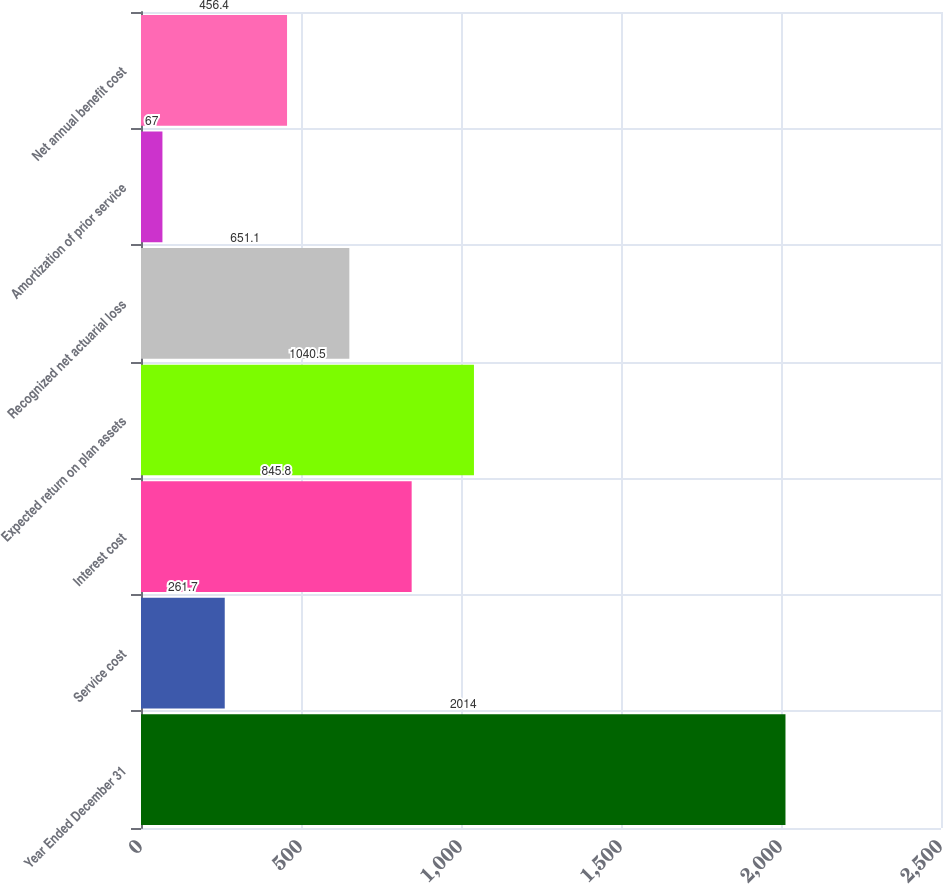<chart> <loc_0><loc_0><loc_500><loc_500><bar_chart><fcel>Year Ended December 31<fcel>Service cost<fcel>Interest cost<fcel>Expected return on plan assets<fcel>Recognized net actuarial loss<fcel>Amortization of prior service<fcel>Net annual benefit cost<nl><fcel>2014<fcel>261.7<fcel>845.8<fcel>1040.5<fcel>651.1<fcel>67<fcel>456.4<nl></chart> 